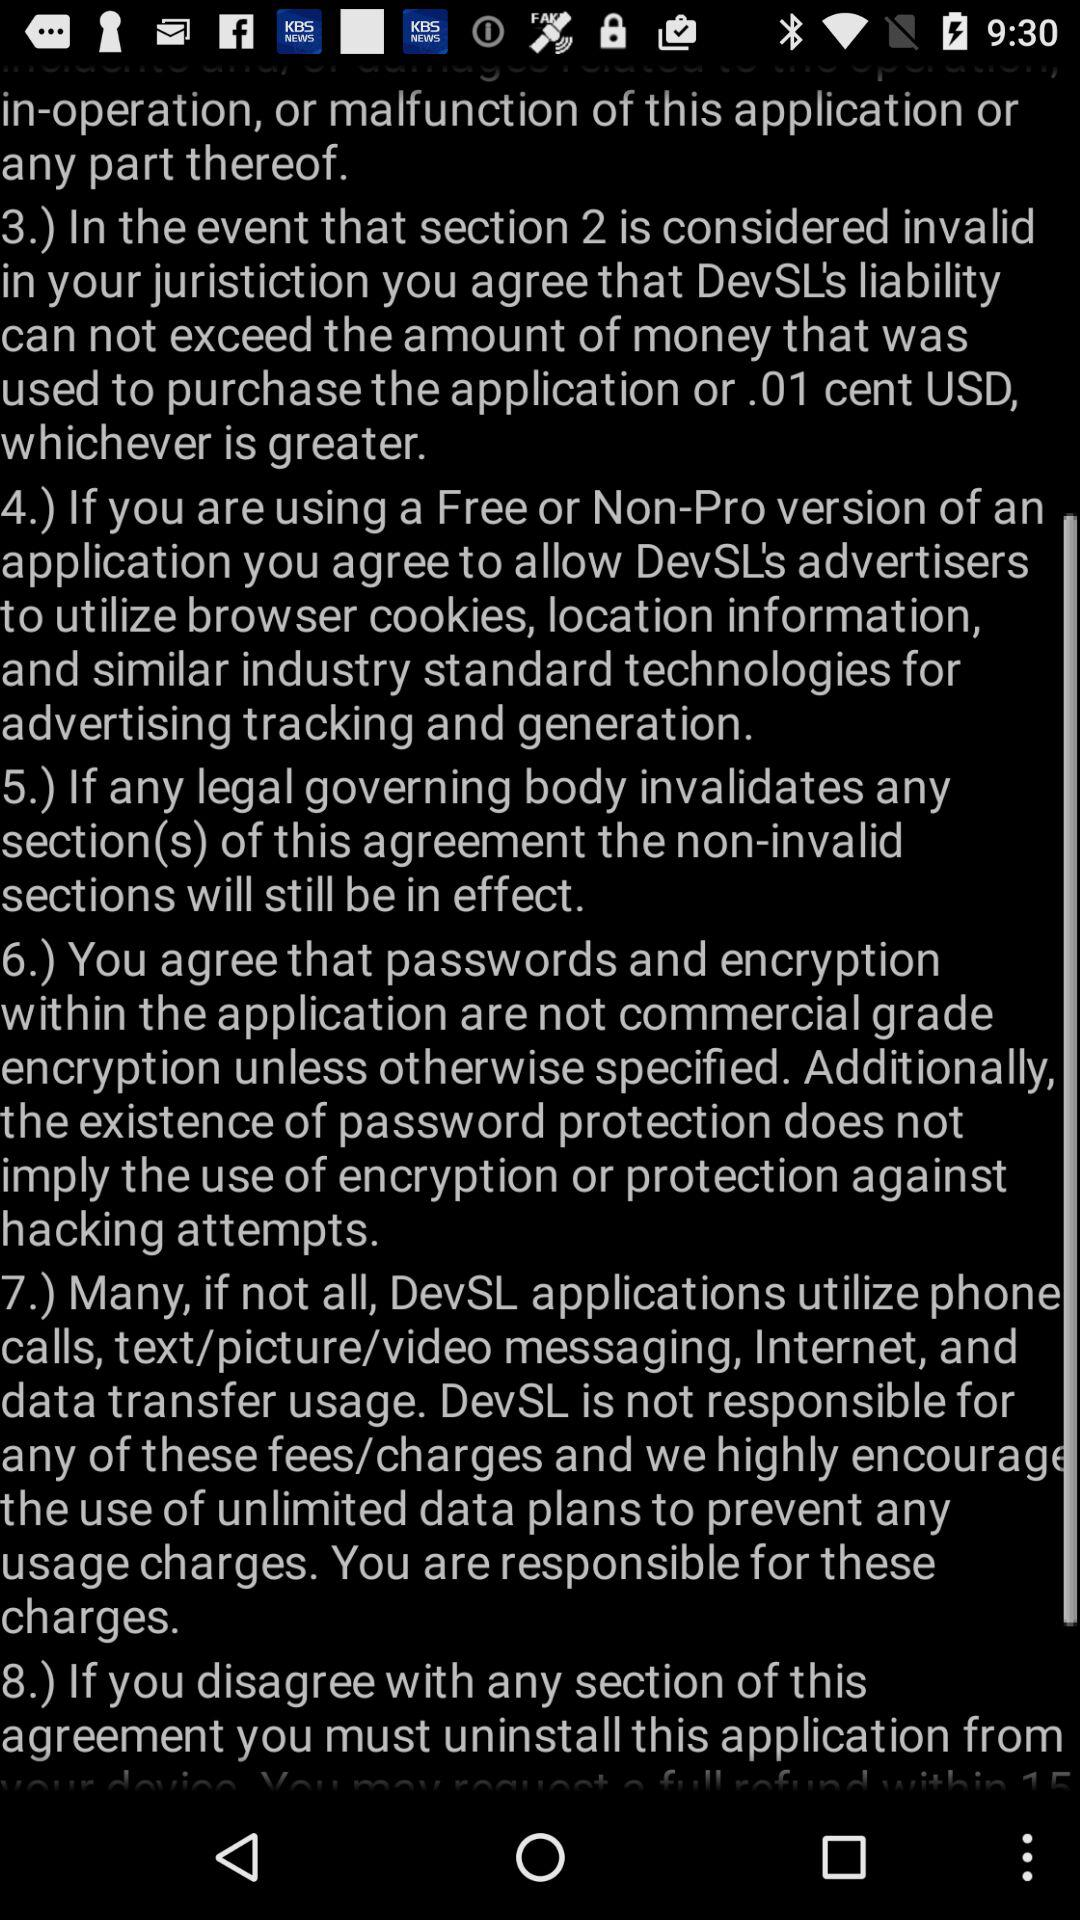What happens if a section of the agreement is invalidated? If any legal governing body invalidates a section of this agreement, according to section 5, the non-invalid sections will still be in effect, ensuring the remainder of the agreement remains operational and binding. Is there any mention of liability relating to the use of the application? Yes, there is. Section 3 touches on liability, stating that in the event of an invalidated section, DevSL's liability cannot exceed either the amount of money used to purchase the application or 0.01 USD, whichever is greater. 